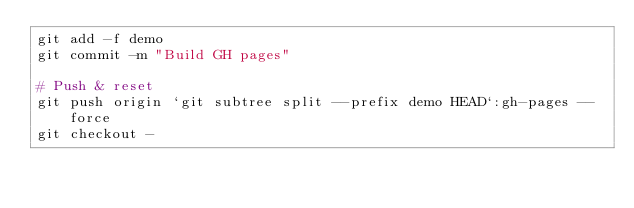<code> <loc_0><loc_0><loc_500><loc_500><_Bash_>git add -f demo
git commit -m "Build GH pages"

# Push & reset
git push origin `git subtree split --prefix demo HEAD`:gh-pages --force
git checkout -</code> 